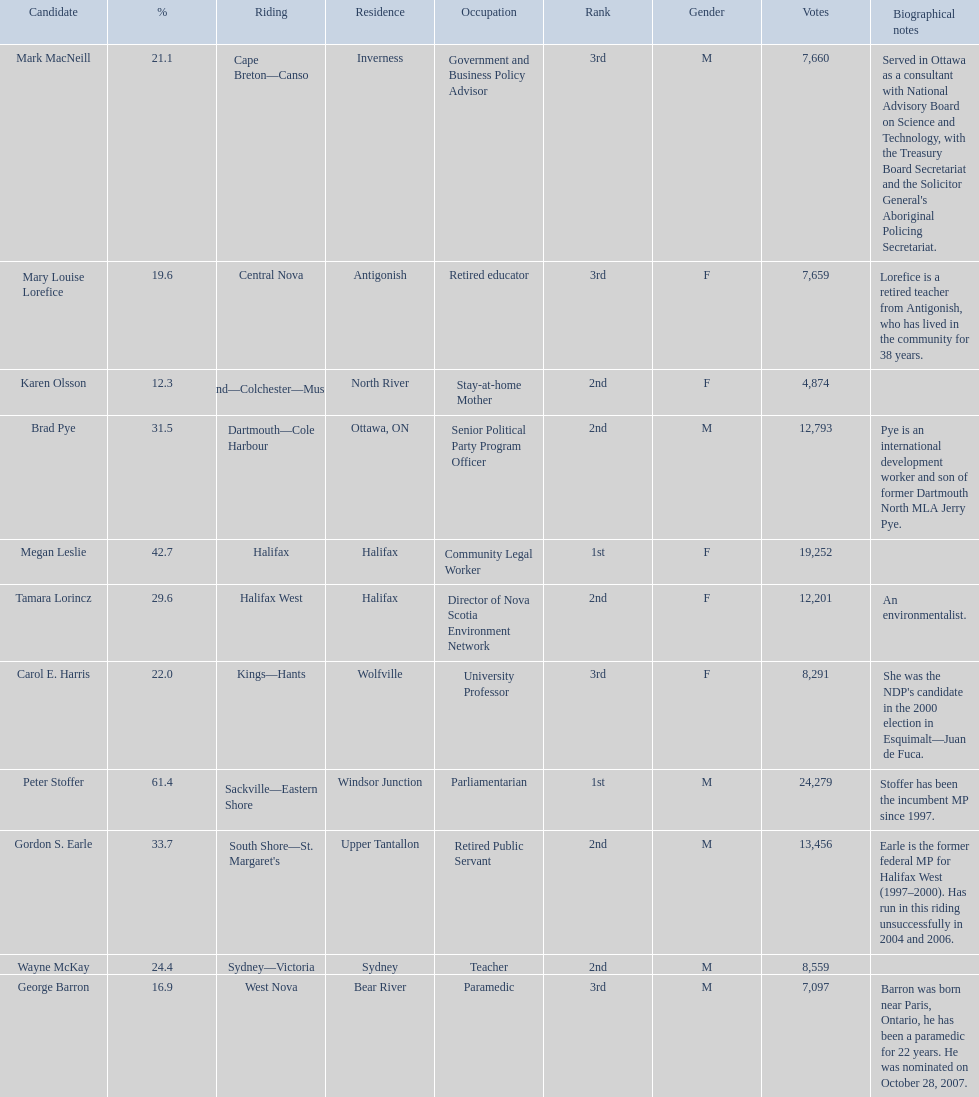How many of the candidates were females? 5. 